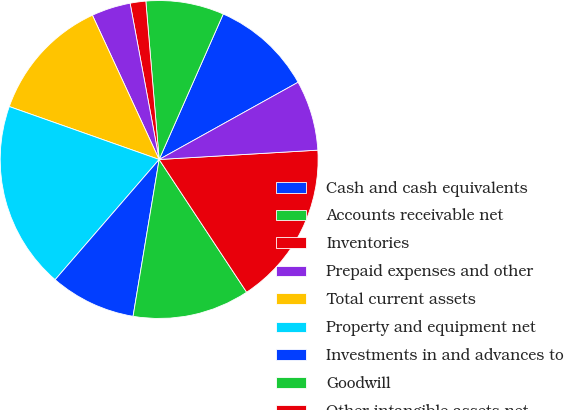Convert chart. <chart><loc_0><loc_0><loc_500><loc_500><pie_chart><fcel>Cash and cash equivalents<fcel>Accounts receivable net<fcel>Inventories<fcel>Prepaid expenses and other<fcel>Total current assets<fcel>Property and equipment net<fcel>Investments in and advances to<fcel>Goodwill<fcel>Other intangible assets net<fcel>Other long-term assets net<nl><fcel>10.32%<fcel>7.94%<fcel>1.59%<fcel>3.97%<fcel>12.7%<fcel>19.05%<fcel>8.73%<fcel>11.9%<fcel>16.66%<fcel>7.14%<nl></chart> 